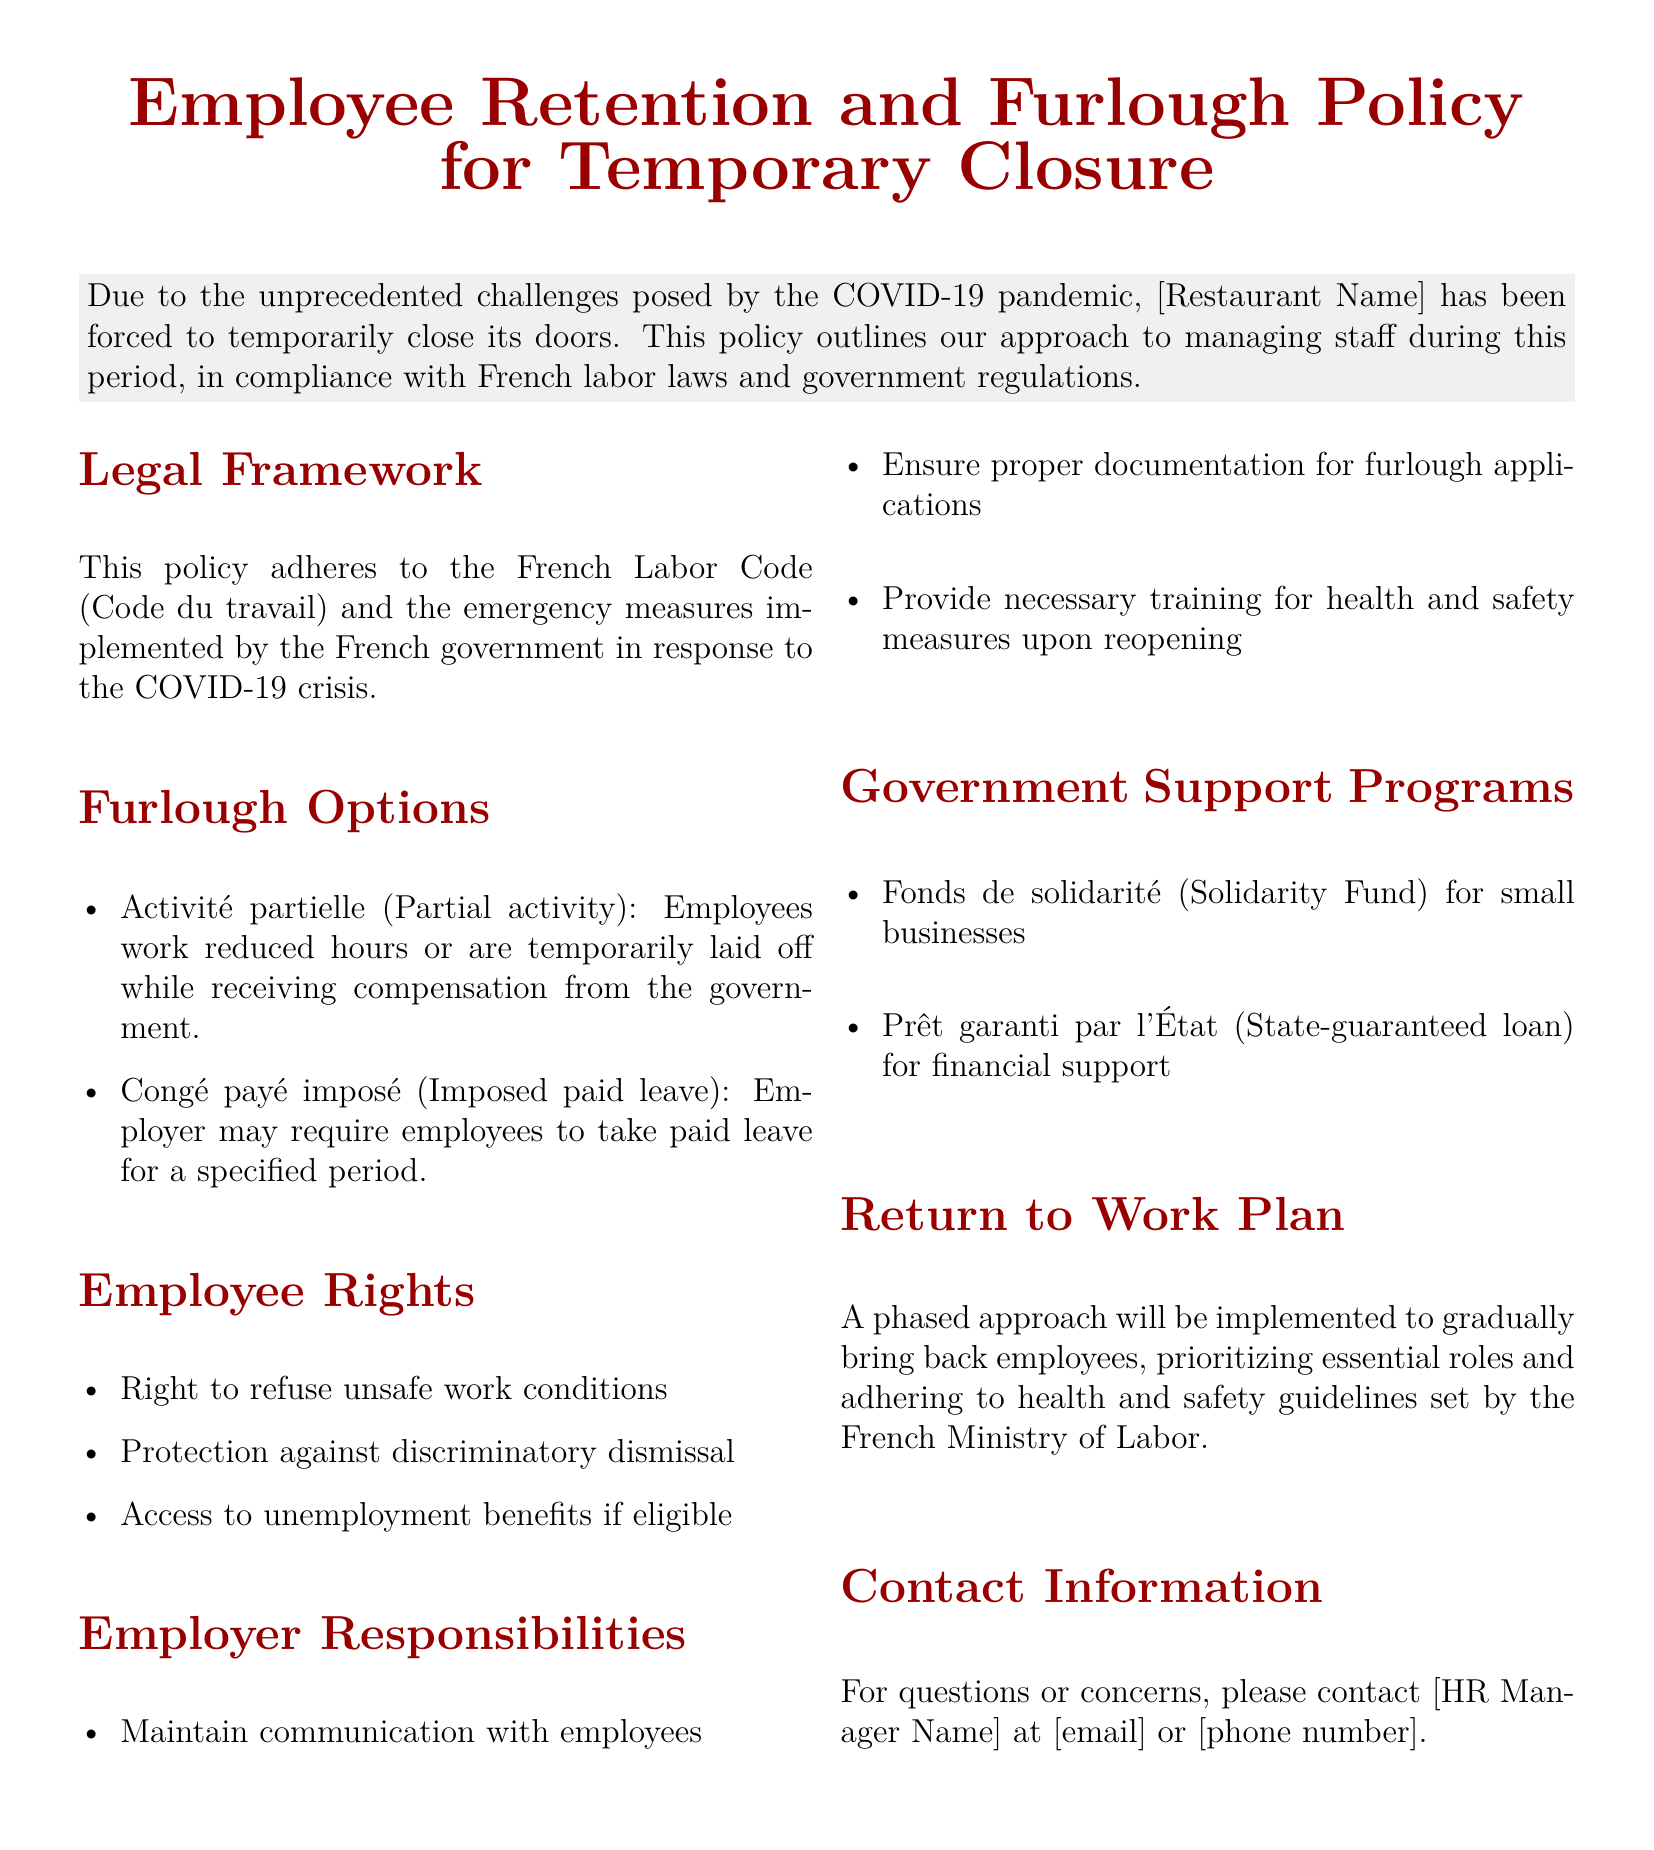What is the legal framework governing this policy? The legal framework refers to the laws and regulations that the policy adheres to, which include the French Labor Code and emergency measures implemented by the French government.
Answer: French Labor Code What are the two furlough options mentioned? The two furlough options provided in the document outline different ways to manage employee work hours or compensation during temporary closure.
Answer: Activité partielle, Congé payé imposé What right do employees have regarding unsafe work conditions? This question addresses employees' rights as outlined in the document, focusing on their ability to refuse work that may pose a danger.
Answer: Right to refuse unsafe work conditions What is one of the employer's responsibilities listed? This question looks for a specific responsibility of the employer that is crucial for maintaining communication and employee support.
Answer: Maintain communication with employees What type of loan is mentioned as government support? The document specifies financial assistance available to businesses during the pandemic, including certain government-backed loan options.
Answer: Prêt garanti par l'État What is the purpose of the Fonds de solidarité? This question seeks to identify the specific function of the government support program mentioned, relating to aid for small businesses.
Answer: Solidarity Fund for small businesses What should the return to work plan prioritize? The response to this question outlines the main focus during the transition back to work, as indicated in the policy.
Answer: Essential roles Who should be contacted for questions or concerns? This question identifies the point of contact within the organization for any inquiries related to the policy.
Answer: HR Manager Name 